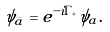Convert formula to latex. <formula><loc_0><loc_0><loc_500><loc_500>\psi _ { \bar { a } } = e ^ { - i \Gamma _ { + } } \psi _ { a } .</formula> 